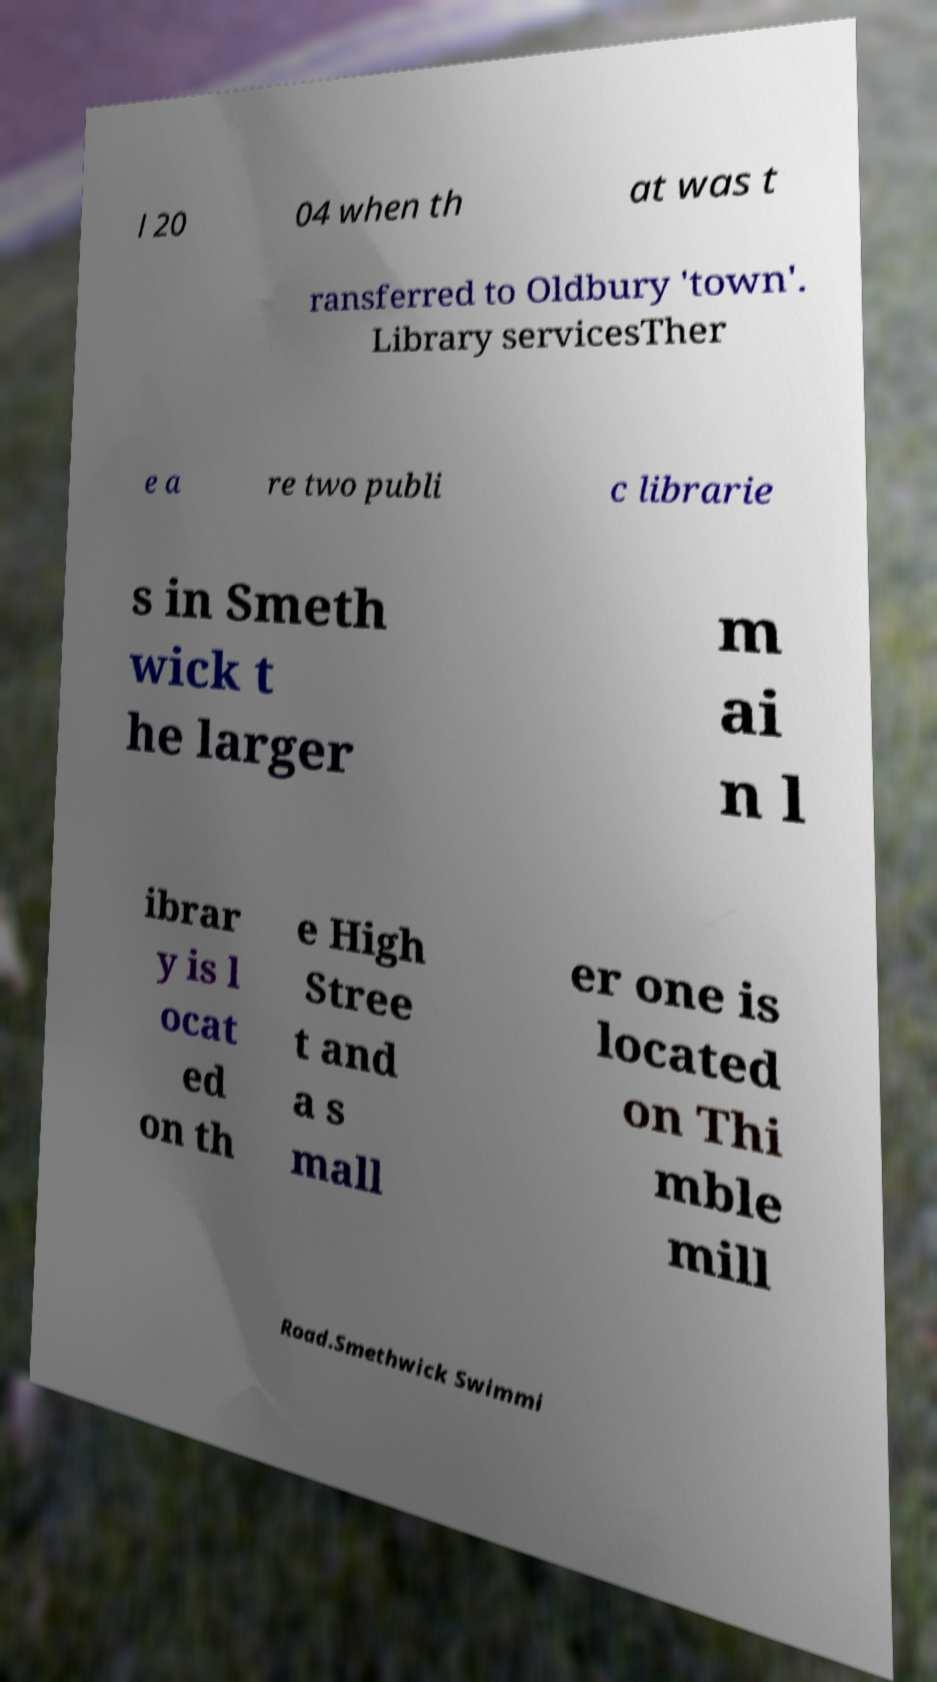Can you read and provide the text displayed in the image?This photo seems to have some interesting text. Can you extract and type it out for me? l 20 04 when th at was t ransferred to Oldbury 'town'. Library servicesTher e a re two publi c librarie s in Smeth wick t he larger m ai n l ibrar y is l ocat ed on th e High Stree t and a s mall er one is located on Thi mble mill Road.Smethwick Swimmi 